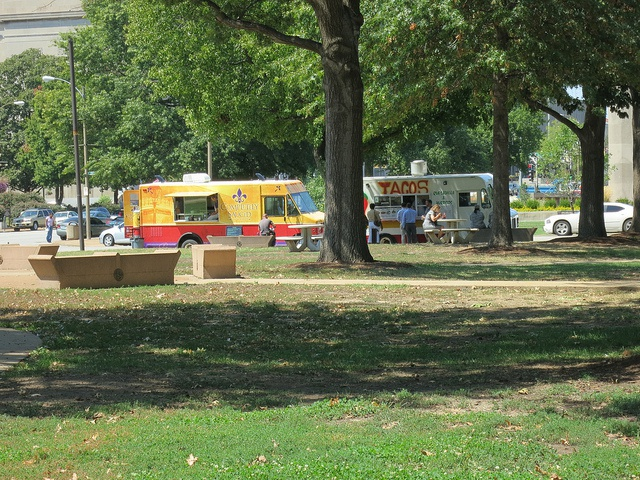Describe the objects in this image and their specific colors. I can see truck in lightgray, gold, ivory, orange, and gray tones, truck in lightgray, gray, black, and darkgray tones, bench in lightgray, gray, black, and olive tones, car in lightgray, white, gray, darkgray, and black tones, and bench in lightgray, gray, and tan tones in this image. 